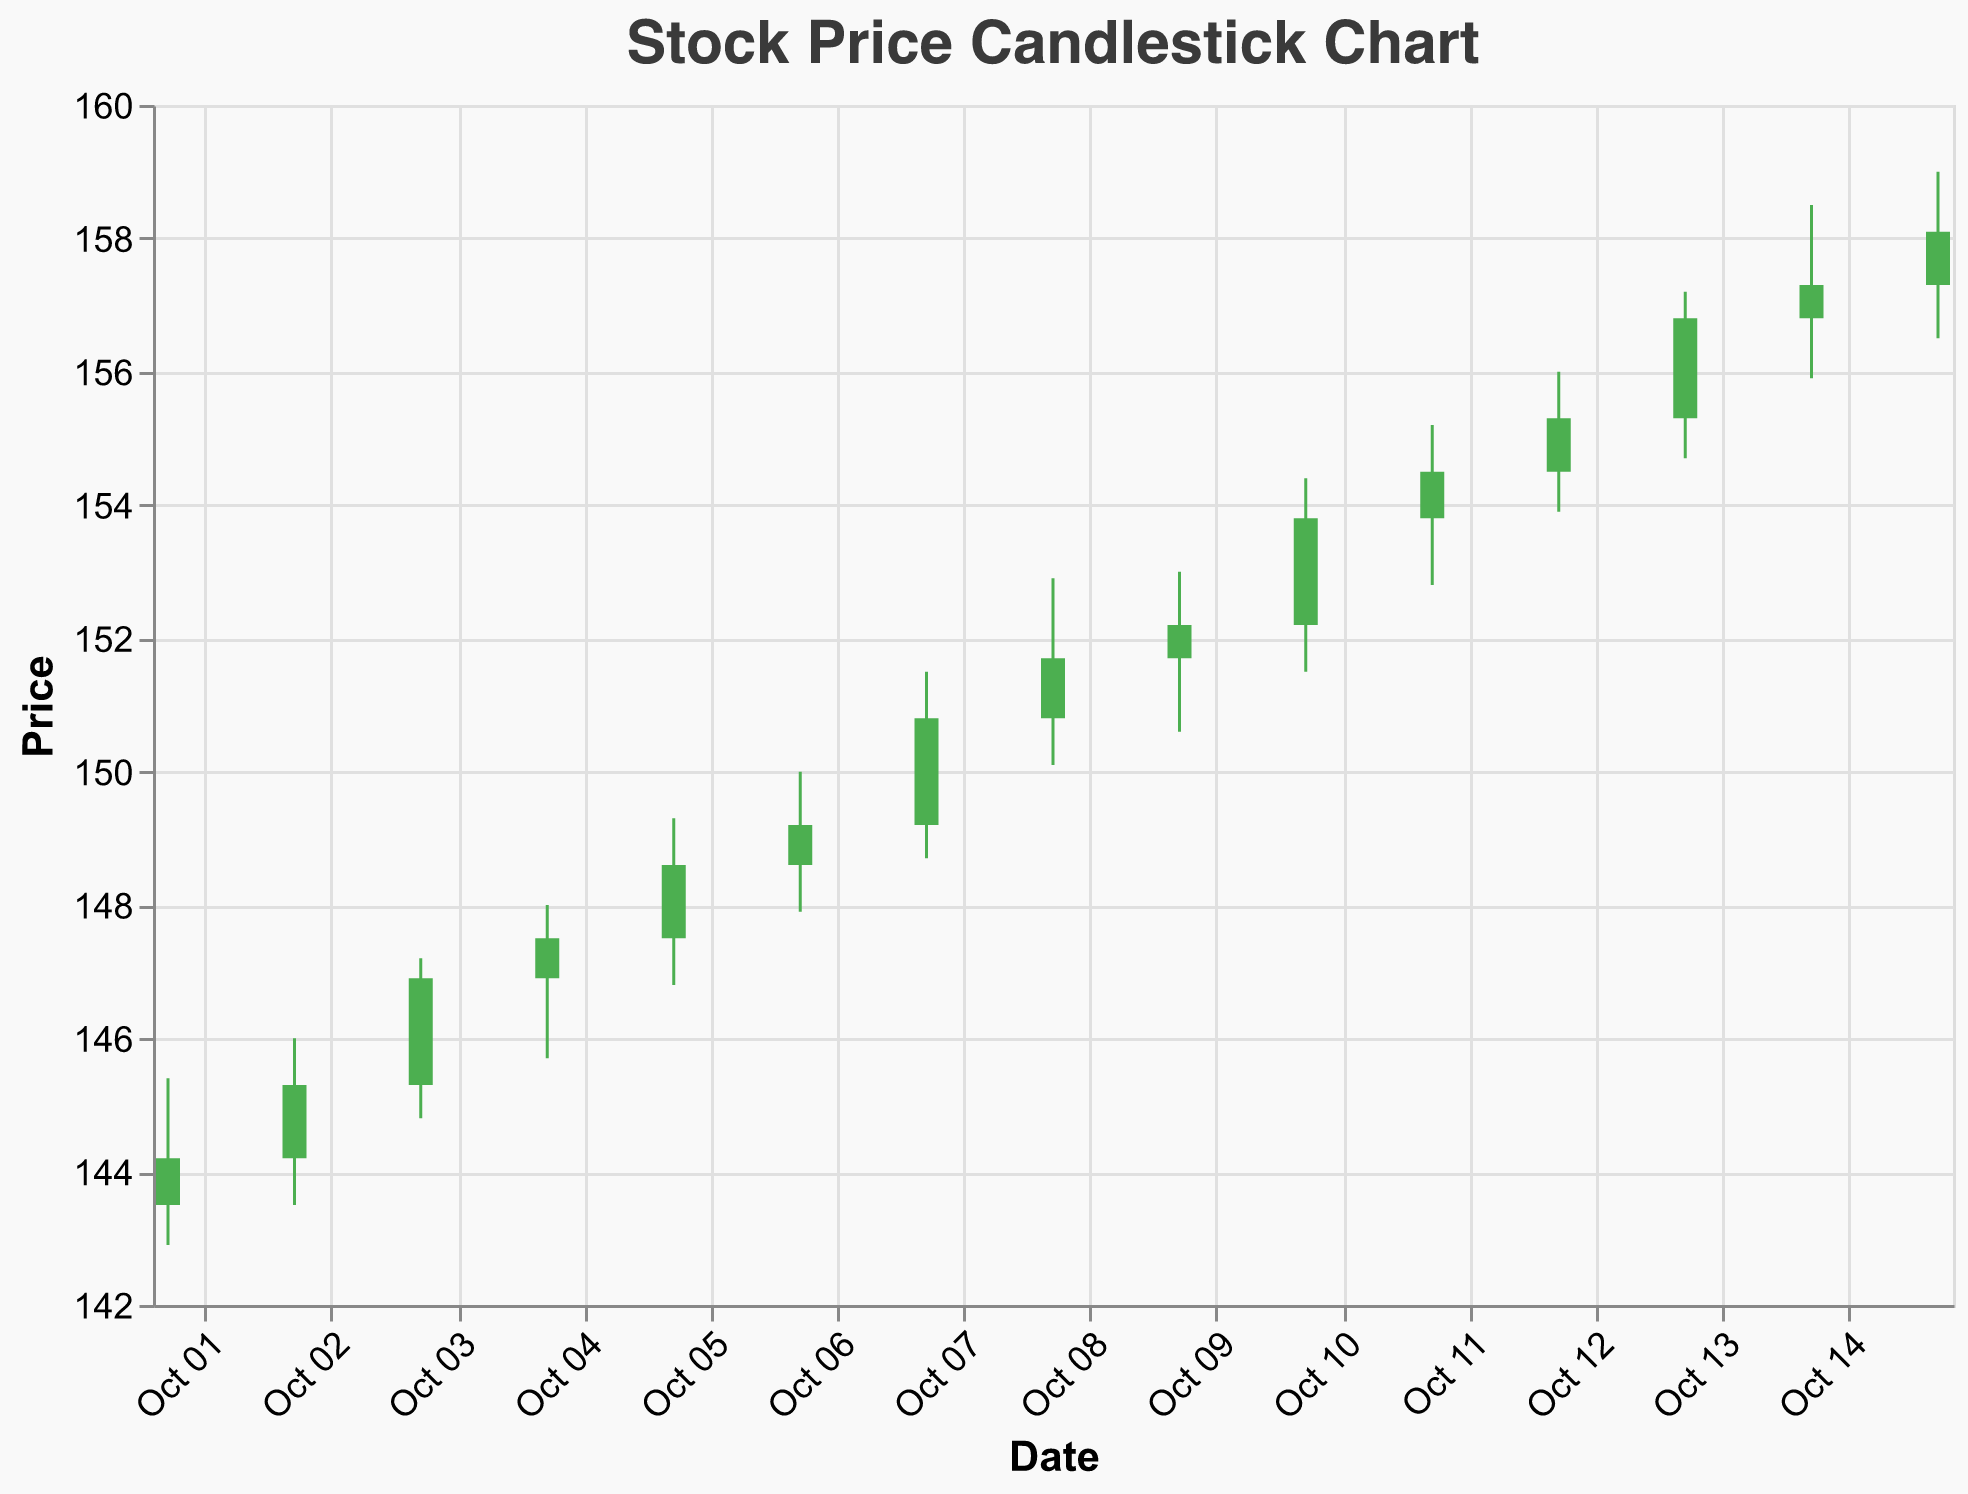What is the title of the figure? The title of the figure is displayed at the top and is centered. It reads "Stock Price Candlestick Chart".
Answer: Stock Price Candlestick Chart What is the highest price recorded during the period shown in the figure? To find the highest price recorded, look for the tallest vertical line representing the "High" value. The highest price is on October 15 at 159.00.
Answer: 159.00 What is the lowest closing price during the period? Examine the boxes and find the lowest point on the lower edges of the boxes that represent the "Close" values. The lowest closing price is on October 1 at 144.20.
Answer: 144.20 How many data points are shown in the figure? Count the number of candlesticks or data entries. There are 15 data points represented by 15 candlesticks.
Answer: 15 On which date did the stock price have the highest volume traded, and what was that volume? Consult the data points for "Volume" and identify the candlestick with the highest volume. On October 15, the volume traded was the highest at 1,524,500.
Answer: October 15, 1,524,500 What is the average closing price over the period shown? Sum all the closing prices and divide by the number of days (15). The total closing prices amounts to 2,315.70; dividing this by 15 gives an average of approximately 154.38.
Answer: 154.38 Which day had the smallest difference between the high and low prices, and what was that difference? Calculate the difference between the high and low prices for each day, and identify the smallest difference. On October 11, the difference between the high (155.20) and the low (152.80) is 2.40, which is the smallest.
Answer: October 11, 2.40 Compare the closing price of October 01 to October 15. How much did it increase or decrease? The closing price on October 01 was 144.20 and on October 15 it was 158.10. The increase is equal to 158.10 - 144.20 = 13.90.
Answer: 13.90 What is the longest duration (in days) where the stock price increased consecutively? Observing the figure, the stock price increases consecutively from October 01 to October 03 (3 days), from October 06 to October 10 (5 days), and again from October 12 to October 15 (4 days). The longest period is 5 days from October 06 to October 10.
Answer: 5 days Which date had the largest single-day gain (difference between open and close) in stock price? Evaluate the difference between open and close for each date. The largest gain occurred on October 14, where the closing price (157.30) increased from the opening price (156.80) by 0.50.
Answer: October 14 